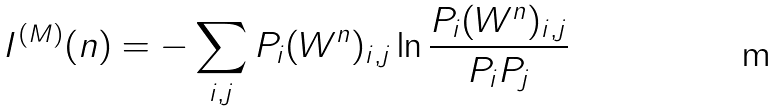<formula> <loc_0><loc_0><loc_500><loc_500>I ^ { ( M ) } ( n ) = - \sum _ { i , j } P _ { i } ( W ^ { n } ) _ { i , j } \ln \frac { P _ { i } ( W ^ { n } ) _ { i , j } } { P _ { i } P _ { j } }</formula> 